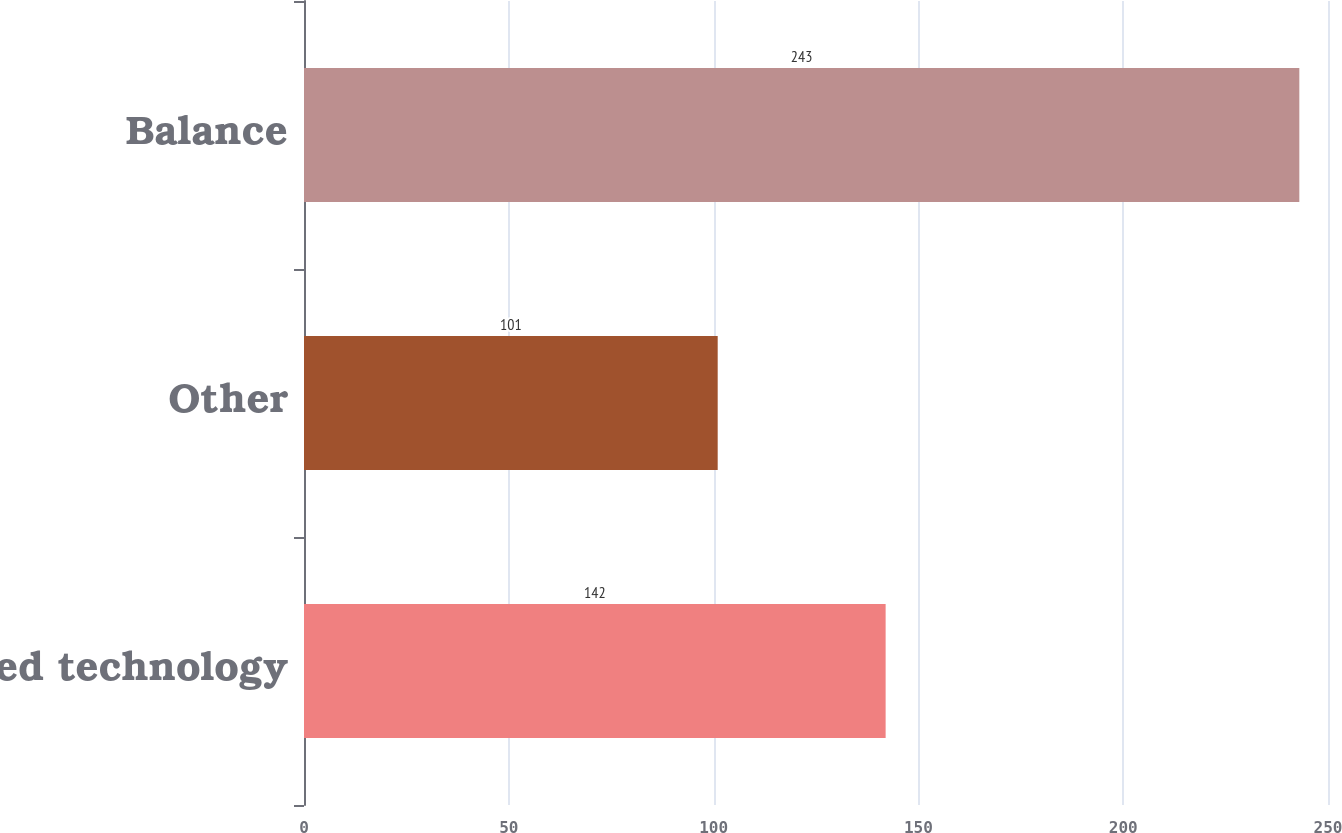Convert chart. <chart><loc_0><loc_0><loc_500><loc_500><bar_chart><fcel>Acquired technology<fcel>Other<fcel>Balance<nl><fcel>142<fcel>101<fcel>243<nl></chart> 